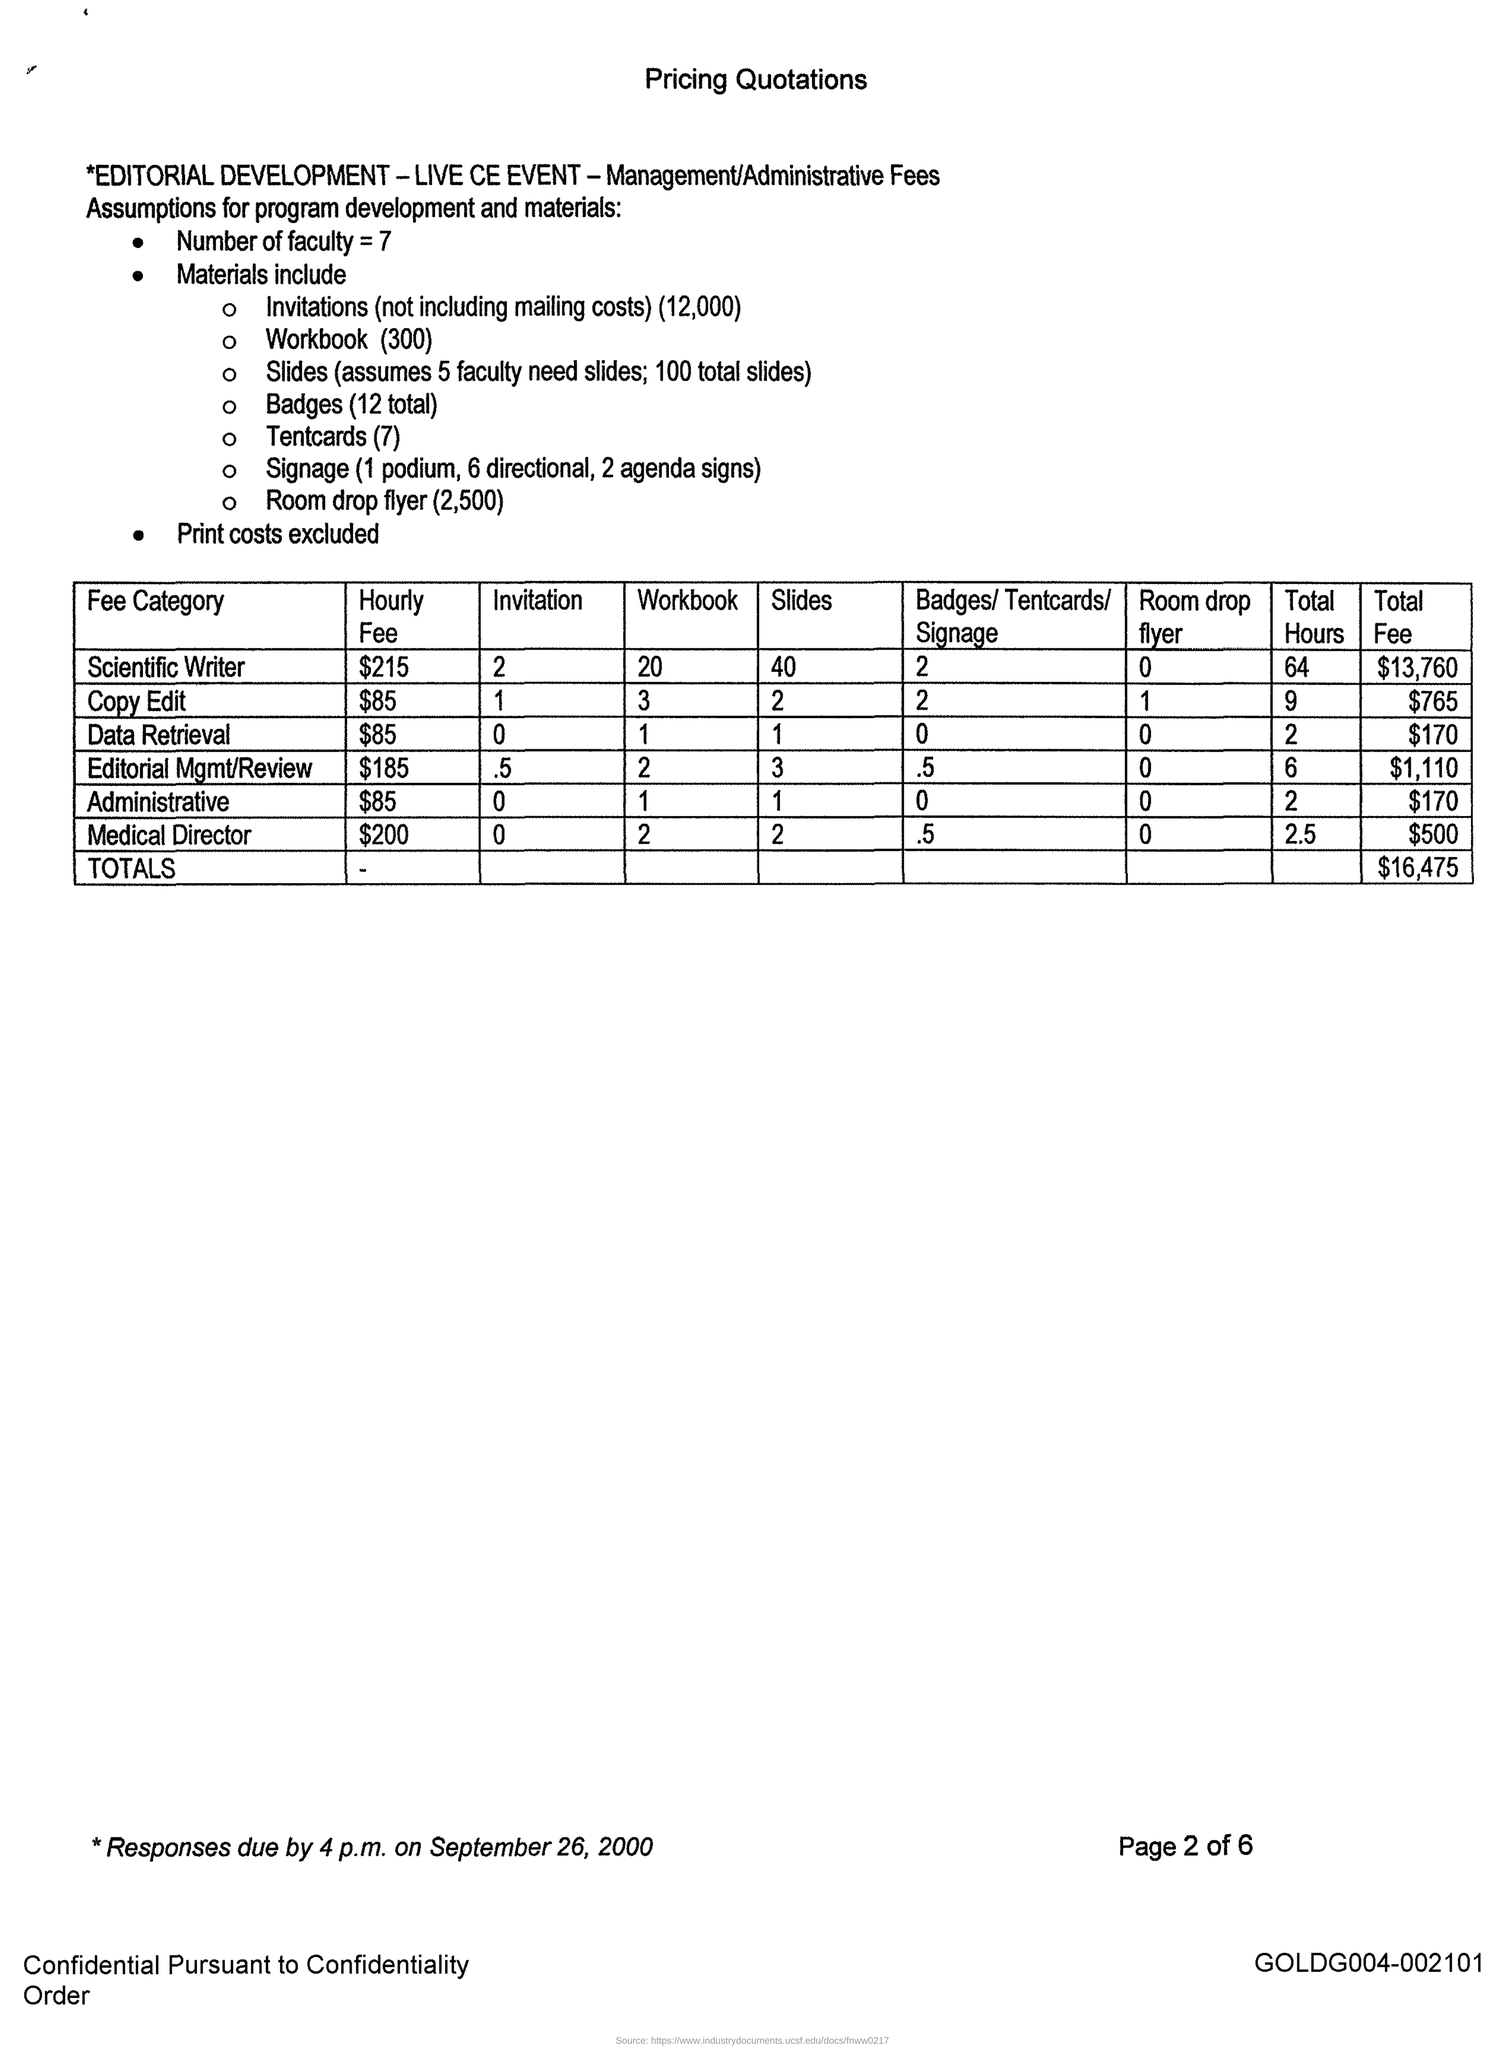Highlight a few significant elements in this photo. The hourly fee for a scientific writer is $215. The number of slides used by scientific writers is typically around 40. The total cost of the pricing quotation is $16,475. There are 7 faculty members. 